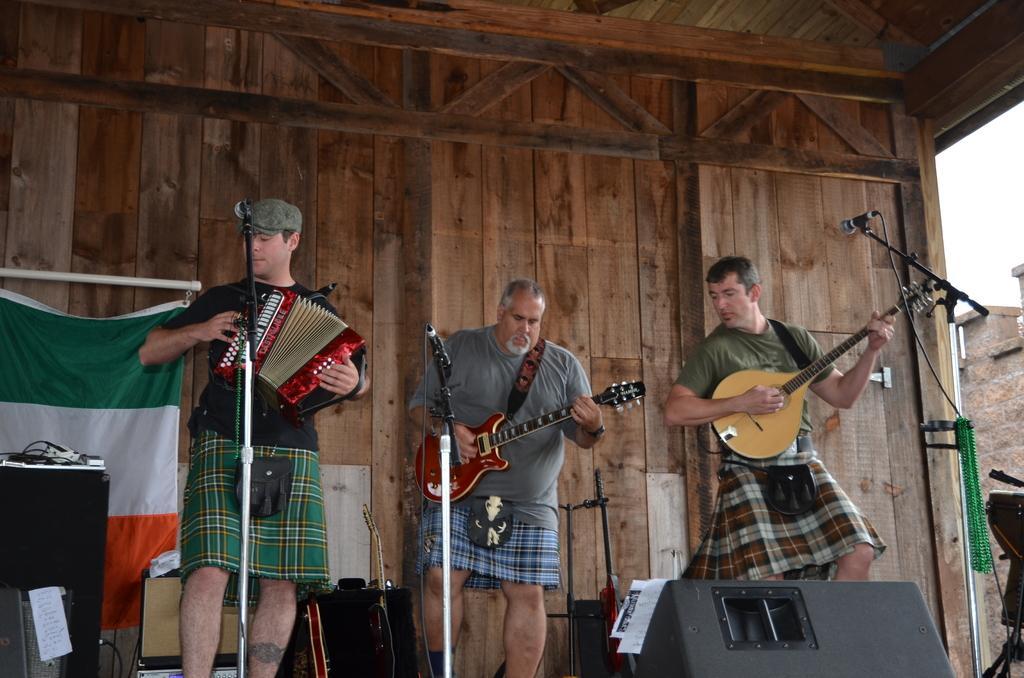Could you give a brief overview of what you see in this image? In the image we can see there are people who are standing and they are holding musical instruments in their hand. 